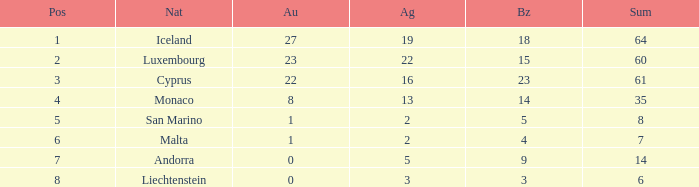How many bronzes for nations with over 22 golds and ranked under 2? 18.0. 